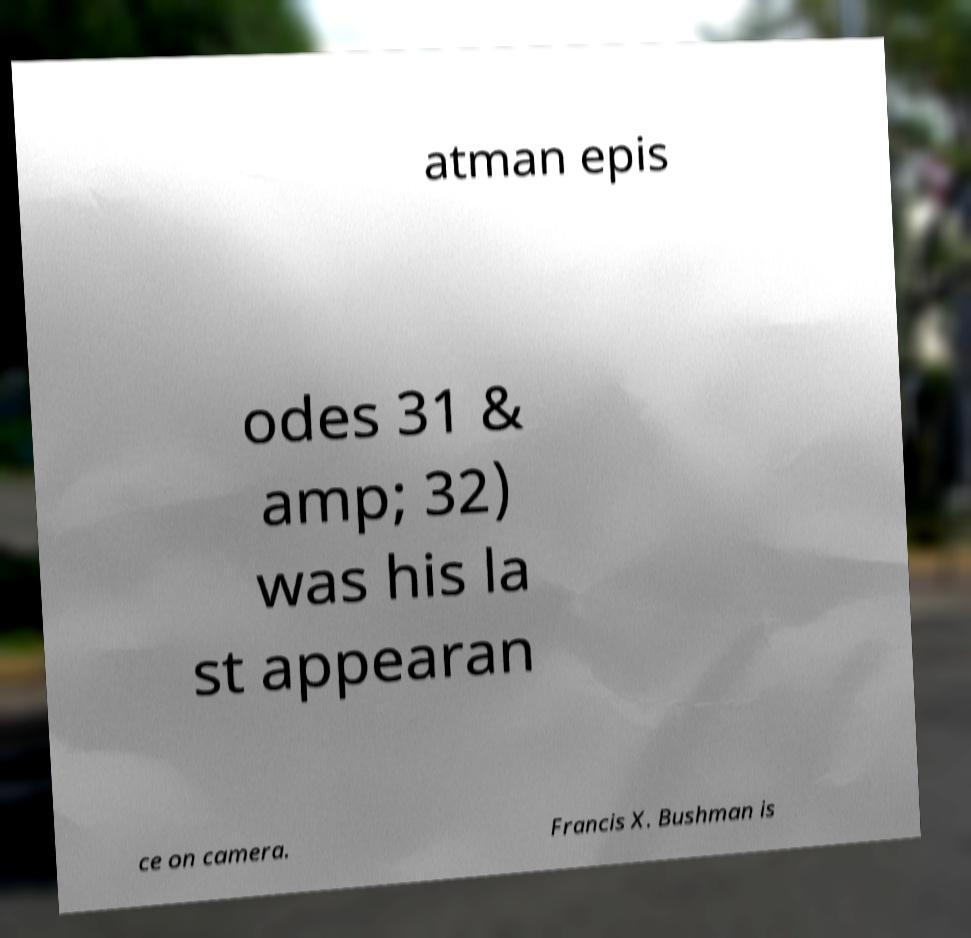Can you accurately transcribe the text from the provided image for me? atman epis odes 31 & amp; 32) was his la st appearan ce on camera. Francis X. Bushman is 